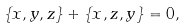<formula> <loc_0><loc_0><loc_500><loc_500>\{ x , y , z \} + \{ x , z , y \} = 0 ,</formula> 